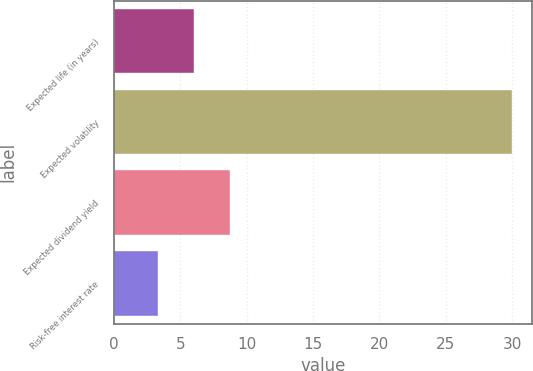Convert chart. <chart><loc_0><loc_0><loc_500><loc_500><bar_chart><fcel>Expected life (in years)<fcel>Expected volatility<fcel>Expected dividend yield<fcel>Risk-free interest rate<nl><fcel>6<fcel>30<fcel>8.7<fcel>3.3<nl></chart> 